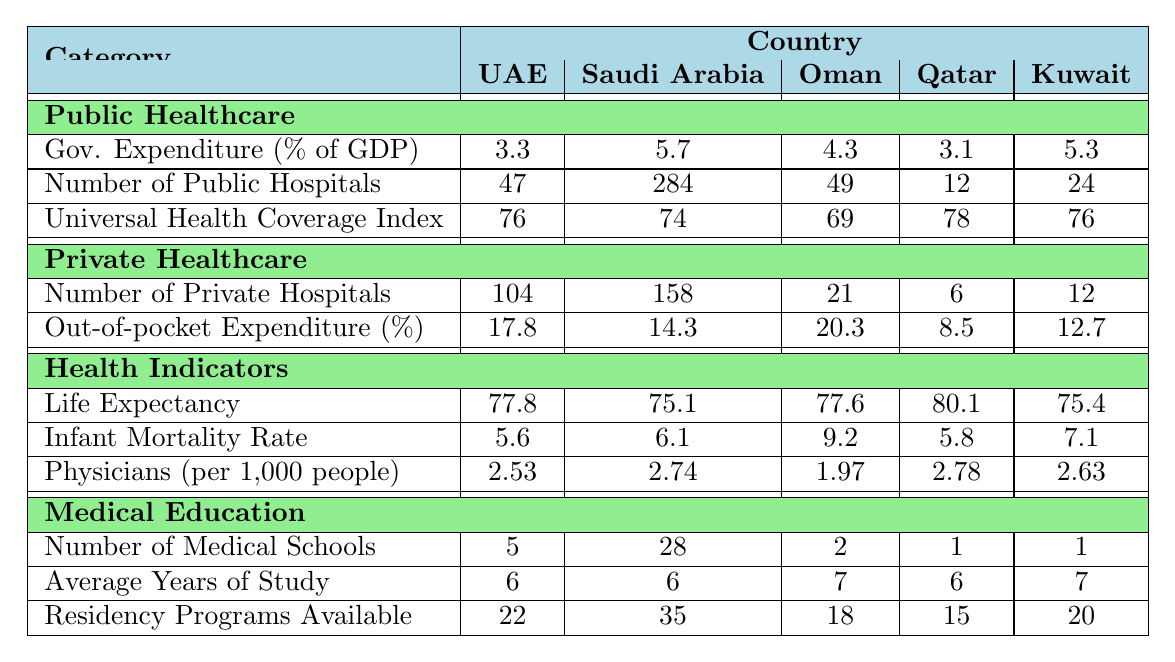What is the number of public hospitals in the UAE? The table indicates that the number of public hospitals in the UAE is explicitly stated in the "Public Healthcare" section under "Number of Public Hospitals." It shows a value of 47.
Answer: 47 How does the government expenditure on public healthcare in Saudi Arabia compare to that of Qatar? By comparing the values in the "Government Expenditure (% of GDP)" row under "Public Healthcare," Saudi Arabia has 5.7%, while Qatar has 3.1%. Thus, Saudi Arabia has a higher government expenditure on public healthcare than Qatar.
Answer: Saudi Arabia has a higher expenditure What is the average out-of-pocket expenditure percentage across all five countries? To find the average, sum the out-of-pocket expenditure percentages: (17.8 + 14.3 + 20.3 + 8.5 + 12.7) = 73.6. Then divide by the number of countries (5): 73.6 / 5 = 14.72%.
Answer: 14.72% Which country has the highest life expectancy among the listed countries? Looking at the "Life Expectancy" row under "Health Indicators," Qatar has the highest value at 80.1 years, which is greater than the other countries listed.
Answer: Qatar Is it true that Oman has a higher infant mortality rate than Kuwait? The table shows that Oman has an infant mortality rate of 9.2 (per 1,000 live births), while Kuwait has 7.1. Since 9.2 is greater than 7.1, it is true that Oman has a higher infant mortality rate.
Answer: True What is the difference in the number of private hospitals between Saudi Arabia and Oman? The table specifies that Saudi Arabia has 158 private hospitals, while Oman has 21. To find the difference, subtract 21 from 158, resulting in 137.
Answer: 137 Which country has a higher number of medical schools, the UAE or Kuwait? According to the "Medical Education" section, the UAE has 5 medical schools, while Kuwait has only 1. Thus, the UAE has a higher number of medical schools compared to Kuwait.
Answer: UAE If you combine the total number of public hospitals in the UAE and Oman, what is the sum? The UAE has 47 public hospitals and Oman has 49. Summing these gives 47 + 49 = 96 public hospitals in total.
Answer: 96 How many countries have a universal health coverage index higher than that of Saudi Arabia? Saudi Arabia has a universal health coverage index of 74. Looking at the data, both Qatar (78) and UAE (76) have higher scores. Therefore, there are 2 countries with a higher index than Saudi Arabia.
Answer: 2 What is the average number of residency programs available across all listed countries? The total number of residency programs available across countries is 22 (UAE) + 35 (Saudi Arabia) + 18 (Oman) + 15 (Qatar) + 20 (Kuwait) = 110. Dividing by the number of countries (5), the average is 110 / 5 = 22.
Answer: 22 